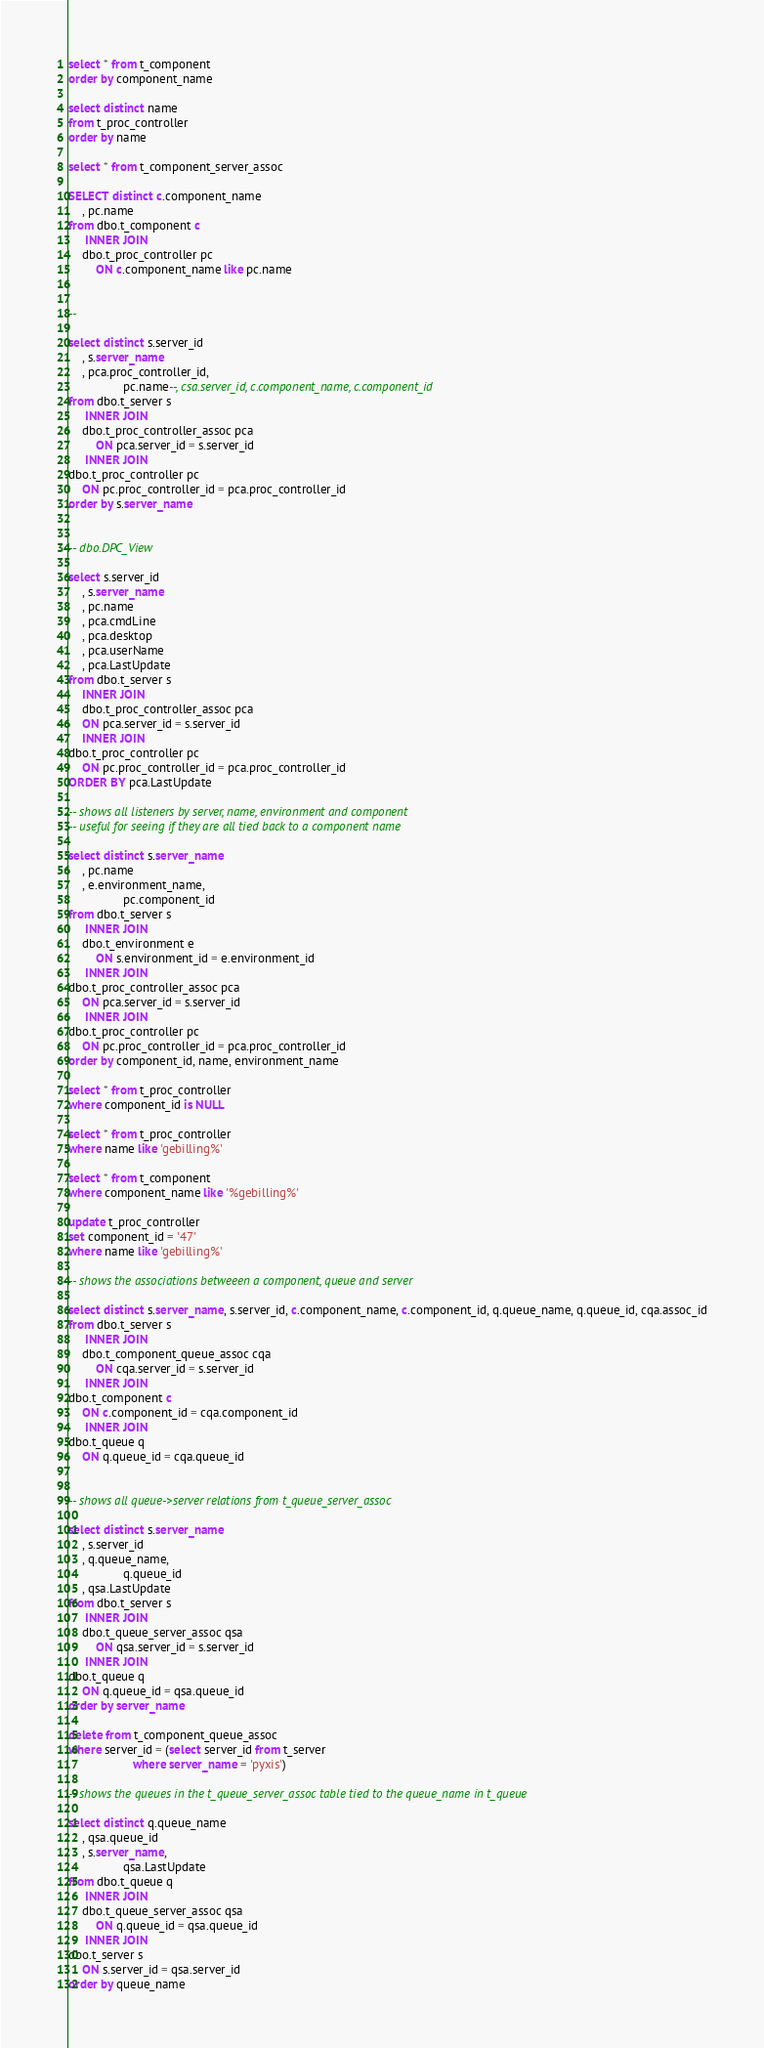Convert code to text. <code><loc_0><loc_0><loc_500><loc_500><_SQL_>
select * from t_component
order by component_name

select distinct name
from t_proc_controller
order by name

select * from t_component_server_assoc

SELECT distinct c.component_name
    , pc.name
from dbo.t_component c
     INNER JOIN
    dbo.t_proc_controller pc
        ON c.component_name like pc.name


-- 

select distinct s.server_id
    , s.server_name
    , pca.proc_controller_id,
                pc.name--, csa.server_id, c.component_name, c.component_id
from dbo.t_server s
     INNER JOIN
    dbo.t_proc_controller_assoc pca
        ON pca.server_id = s.server_id
     INNER JOIN
dbo.t_proc_controller pc
    ON pc.proc_controller_id = pca.proc_controller_id
order by s.server_name   


-- dbo.DPC_View

select s.server_id
    , s.server_name
    , pc.name
    , pca.cmdLine
    , pca.desktop
    , pca.userName
    , pca.LastUpdate
from dbo.t_server s
    INNER JOIN
    dbo.t_proc_controller_assoc pca
    ON pca.server_id = s.server_id
    INNER JOIN
dbo.t_proc_controller pc
    ON pc.proc_controller_id = pca.proc_controller_id
ORDER BY pca.LastUpdate

-- shows all listeners by server, name, environment and component
-- useful for seeing if they are all tied back to a component name

select distinct s.server_name
    , pc.name
    , e.environment_name,
                pc.component_id
from dbo.t_server s
     INNER JOIN
    dbo.t_environment e
        ON s.environment_id = e.environment_id
     INNER JOIN
dbo.t_proc_controller_assoc pca
    ON pca.server_id = s.server_id
     INNER JOIN
dbo.t_proc_controller pc
    ON pc.proc_controller_id = pca.proc_controller_id
order by component_id, name, environment_name

select * from t_proc_controller
where component_id is NULL

select * from t_proc_controller
where name like 'gebilling%'

select * from t_component
where component_name like '%gebilling%'

update t_proc_controller
set component_id = '47'
where name like 'gebilling%'

-- shows the associations betweeen a component, queue and server

select distinct s.server_name, s.server_id, c.component_name, c.component_id, q.queue_name, q.queue_id, cqa.assoc_id
from dbo.t_server s
     INNER JOIN
    dbo.t_component_queue_assoc cqa
        ON cqa.server_id = s.server_id
     INNER JOIN
dbo.t_component c
    ON c.component_id = cqa.component_id
     INNER JOIN
dbo.t_queue q
    ON q.queue_id = cqa.queue_id


-- shows all queue->server relations from t_queue_server_assoc

select distinct s.server_name
    , s.server_id
    , q.queue_name,
                q.queue_id
    , qsa.LastUpdate
from dbo.t_server s
     INNER JOIN
    dbo.t_queue_server_assoc qsa
        ON qsa.server_id = s.server_id
     INNER JOIN
dbo.t_queue q
    ON q.queue_id = qsa.queue_id
order by server_name

delete from t_component_queue_assoc
where server_id = (select server_id from t_server
                   where server_name = 'pyxis')

-- shows the queues in the t_queue_server_assoc table tied to the queue_name in t_queue

select distinct q.queue_name
    , qsa.queue_id
    , s.server_name,
                qsa.LastUpdate
from dbo.t_queue q
     INNER JOIN
    dbo.t_queue_server_assoc qsa
        ON q.queue_id = qsa.queue_id
     INNER JOIN
dbo.t_server s
    ON s.server_id = qsa.server_id
order by queue_name
</code> 